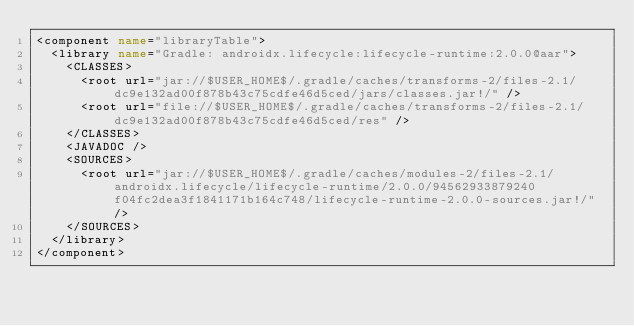<code> <loc_0><loc_0><loc_500><loc_500><_XML_><component name="libraryTable">
  <library name="Gradle: androidx.lifecycle:lifecycle-runtime:2.0.0@aar">
    <CLASSES>
      <root url="jar://$USER_HOME$/.gradle/caches/transforms-2/files-2.1/dc9e132ad00f878b43c75cdfe46d5ced/jars/classes.jar!/" />
      <root url="file://$USER_HOME$/.gradle/caches/transforms-2/files-2.1/dc9e132ad00f878b43c75cdfe46d5ced/res" />
    </CLASSES>
    <JAVADOC />
    <SOURCES>
      <root url="jar://$USER_HOME$/.gradle/caches/modules-2/files-2.1/androidx.lifecycle/lifecycle-runtime/2.0.0/94562933879240f04fc2dea3f1841171b164c748/lifecycle-runtime-2.0.0-sources.jar!/" />
    </SOURCES>
  </library>
</component></code> 